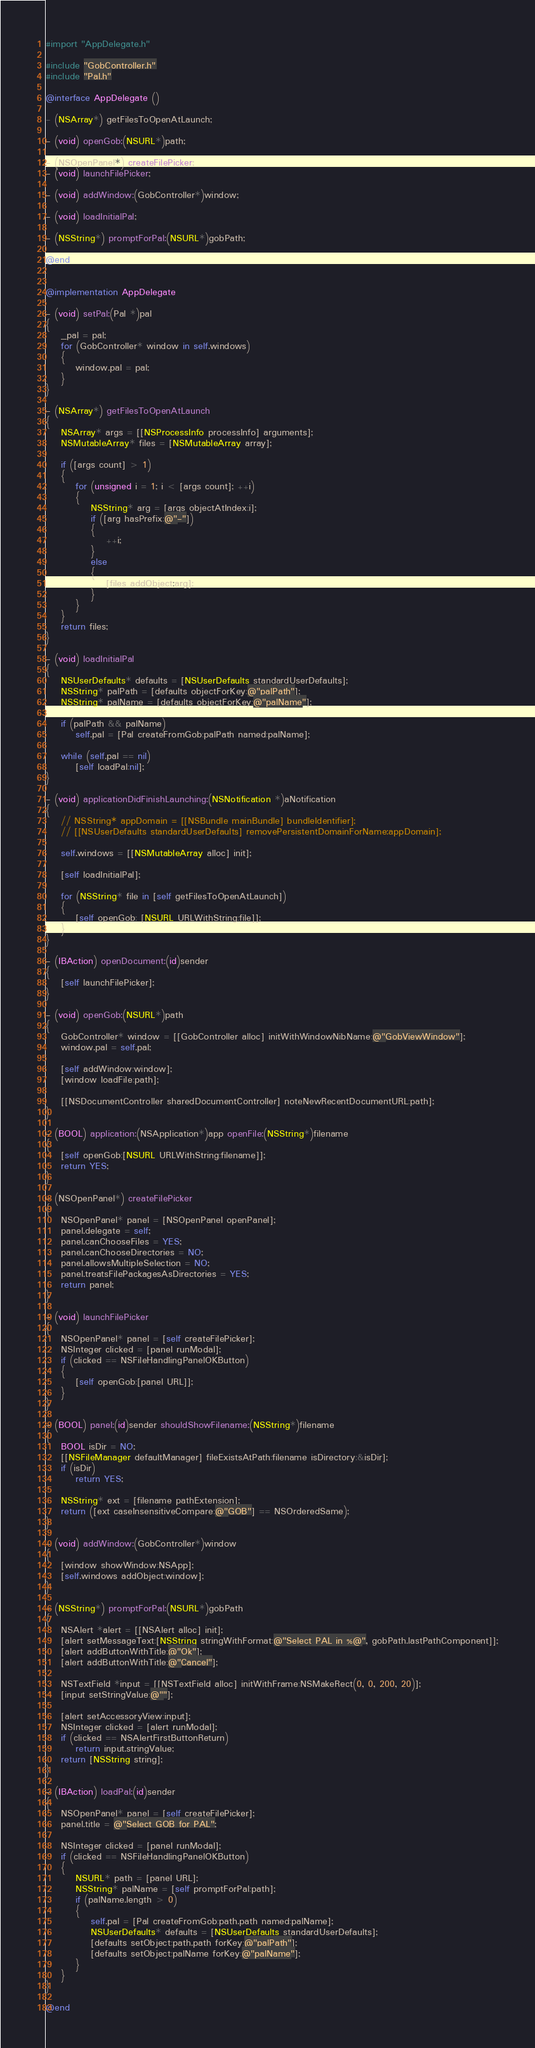Convert code to text. <code><loc_0><loc_0><loc_500><loc_500><_ObjectiveC_>#import "AppDelegate.h"

#include "GobController.h"
#include "Pal.h"

@interface AppDelegate ()

- (NSArray*) getFilesToOpenAtLaunch;

- (void) openGob:(NSURL*)path;

- (NSOpenPanel*) createFilePicker;
- (void) launchFilePicker;

- (void) addWindow:(GobController*)window;

- (void) loadInitialPal;

- (NSString*) promptForPal:(NSURL*)gobPath;

@end


@implementation AppDelegate

- (void) setPal:(Pal *)pal
{
    _pal = pal;
    for (GobController* window in self.windows)
    {
        window.pal = pal;
    }
}

- (NSArray*) getFilesToOpenAtLaunch
{
    NSArray* args = [[NSProcessInfo processInfo] arguments];
    NSMutableArray* files = [NSMutableArray array];
    
    if ([args count] > 1)
    {
        for (unsigned i = 1; i < [args count]; ++i)
        {
            NSString* arg = [args objectAtIndex:i];
            if ([arg hasPrefix:@"-"])
            {
                ++i;
            }
            else
            {
                [files addObject:arg];
            }
        }
    }
    return files;
}

- (void) loadInitialPal
{
    NSUserDefaults* defaults = [NSUserDefaults standardUserDefaults];
    NSString* palPath = [defaults objectForKey:@"palPath"];
    NSString* palName = [defaults objectForKey:@"palName"];
    
    if (palPath && palName)
        self.pal = [Pal createFromGob:palPath named:palName];
    
    while (self.pal == nil)
        [self loadPal:nil];
}

- (void) applicationDidFinishLaunching:(NSNotification *)aNotification
{
    // NSString* appDomain = [[NSBundle mainBundle] bundleIdentifier];
    // [[NSUserDefaults standardUserDefaults] removePersistentDomainForName:appDomain];

    self.windows = [[NSMutableArray alloc] init];
    
    [self loadInitialPal];
    
    for (NSString* file in [self getFilesToOpenAtLaunch])
    {
        [self openGob: [NSURL URLWithString:file]];
    }
}

- (IBAction) openDocument:(id)sender
{
    [self launchFilePicker];
}

- (void) openGob:(NSURL*)path
{
    GobController* window = [[GobController alloc] initWithWindowNibName:@"GobViewWindow"];
    window.pal = self.pal;
    
    [self addWindow:window];
    [window loadFile:path];

    [[NSDocumentController sharedDocumentController] noteNewRecentDocumentURL:path];
}

- (BOOL) application:(NSApplication*)app openFile:(NSString*)filename
{
    [self openGob:[NSURL URLWithString:filename]];
    return YES;
}

- (NSOpenPanel*) createFilePicker
{
    NSOpenPanel* panel = [NSOpenPanel openPanel];
    panel.delegate = self;
    panel.canChooseFiles = YES;
    panel.canChooseDirectories = NO;
    panel.allowsMultipleSelection = NO;
    panel.treatsFilePackagesAsDirectories = YES;
    return panel;
}

- (void) launchFilePicker
{
    NSOpenPanel* panel = [self createFilePicker];
    NSInteger clicked = [panel runModal];
    if (clicked == NSFileHandlingPanelOKButton)
    {
        [self openGob:[panel URL]];
    }
}

- (BOOL) panel:(id)sender shouldShowFilename:(NSString*)filename
{
    BOOL isDir = NO;
    [[NSFileManager defaultManager] fileExistsAtPath:filename isDirectory:&isDir];
    if (isDir)
        return YES;
    
    NSString* ext = [filename pathExtension];
    return ([ext caseInsensitiveCompare:@"GOB"] == NSOrderedSame);
}

- (void) addWindow:(GobController*)window
{
    [window showWindow:NSApp];
    [self.windows addObject:window];
}

- (NSString*) promptForPal:(NSURL*)gobPath
{
    NSAlert *alert = [[NSAlert alloc] init];
    [alert setMessageText:[NSString stringWithFormat:@"Select PAL in %@", gobPath.lastPathComponent]];
    [alert addButtonWithTitle:@"Ok"];
    [alert addButtonWithTitle:@"Cancel"];

    NSTextField *input = [[NSTextField alloc] initWithFrame:NSMakeRect(0, 0, 200, 20)];
    [input setStringValue:@""];

    [alert setAccessoryView:input];
    NSInteger clicked = [alert runModal];
    if (clicked == NSAlertFirstButtonReturn)
        return input.stringValue;
    return [NSString string];
}

- (IBAction) loadPal:(id)sender
{
    NSOpenPanel* panel = [self createFilePicker];
    panel.title = @"Select GOB for PAL";
    
    NSInteger clicked = [panel runModal];
    if (clicked == NSFileHandlingPanelOKButton)
    {
        NSURL* path = [panel URL];
        NSString* palName = [self promptForPal:path];
        if (palName.length > 0)
        {
            self.pal = [Pal createFromGob:path.path named:palName];
            NSUserDefaults* defaults = [NSUserDefaults standardUserDefaults];
            [defaults setObject:path.path forKey:@"palPath"];
            [defaults setObject:palName forKey:@"palName"];
        }
    }
}

@end
</code> 